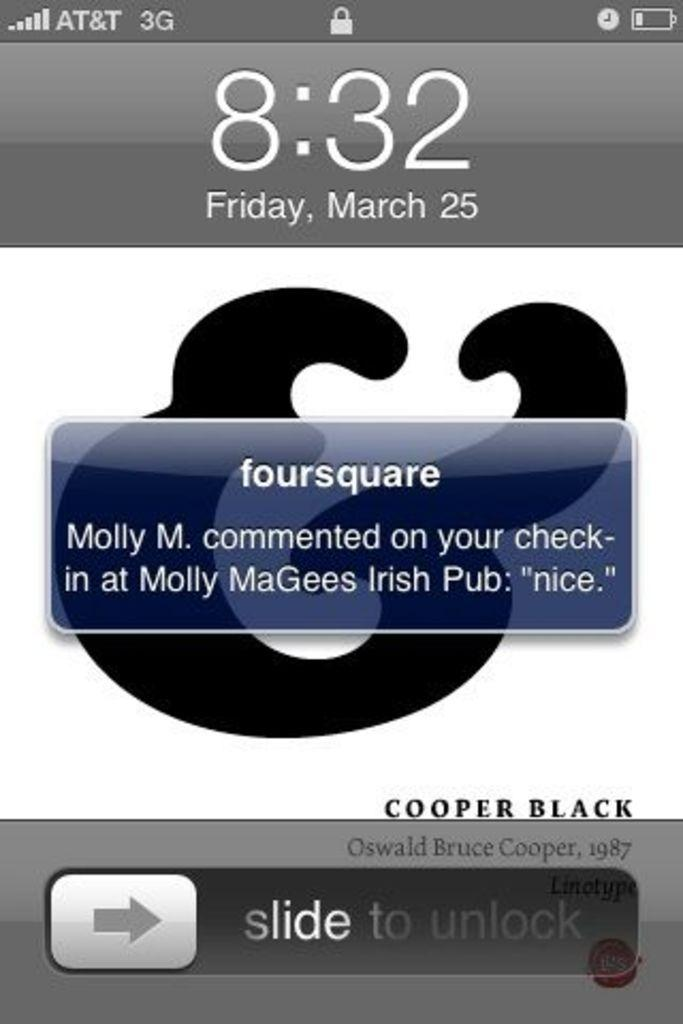<image>
Summarize the visual content of the image. the word foursquare that is on a phone 